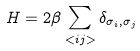Convert formula to latex. <formula><loc_0><loc_0><loc_500><loc_500>H = 2 \beta \sum _ { < i j > } \delta _ { \sigma _ { i } , \sigma _ { j } }</formula> 